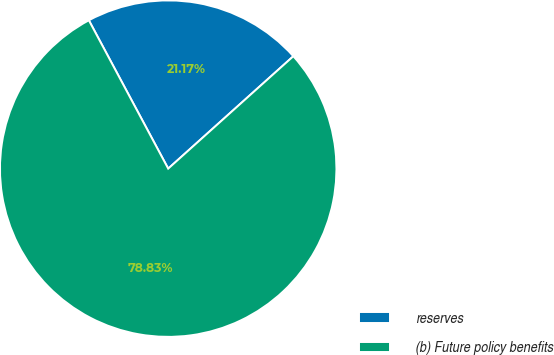Convert chart. <chart><loc_0><loc_0><loc_500><loc_500><pie_chart><fcel>reserves<fcel>(b) Future policy benefits<nl><fcel>21.17%<fcel>78.83%<nl></chart> 